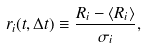Convert formula to latex. <formula><loc_0><loc_0><loc_500><loc_500>r _ { i } ( t , \Delta t ) \equiv \frac { R _ { i } - \langle R _ { i } \rangle } { \sigma _ { i } } ,</formula> 